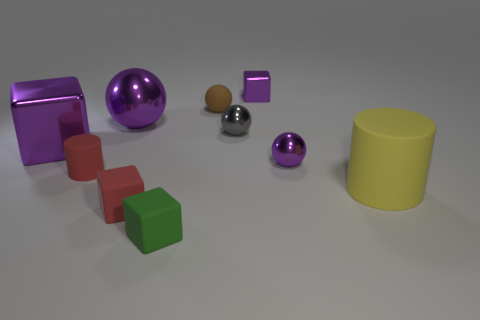The object to the right of the small purple thing that is in front of the tiny brown sphere is what shape?
Make the answer very short. Cylinder. How many other objects are the same shape as the yellow matte object?
Your answer should be compact. 1. Are there any tiny rubber cylinders behind the tiny rubber cylinder?
Make the answer very short. No. The tiny cylinder is what color?
Make the answer very short. Red. There is a matte sphere; does it have the same color as the tiny cube that is behind the large rubber thing?
Your response must be concise. No. Is there a green rubber cube of the same size as the yellow rubber object?
Your response must be concise. No. What size is the cube that is the same color as the small matte cylinder?
Offer a very short reply. Small. What material is the big thing right of the small brown matte ball?
Your response must be concise. Rubber. Is the number of green rubber cubes on the right side of the brown thing the same as the number of purple spheres to the right of the gray metal ball?
Your response must be concise. No. Does the shiny block that is in front of the large purple shiny sphere have the same size as the rubber cylinder in front of the red cylinder?
Make the answer very short. Yes. 